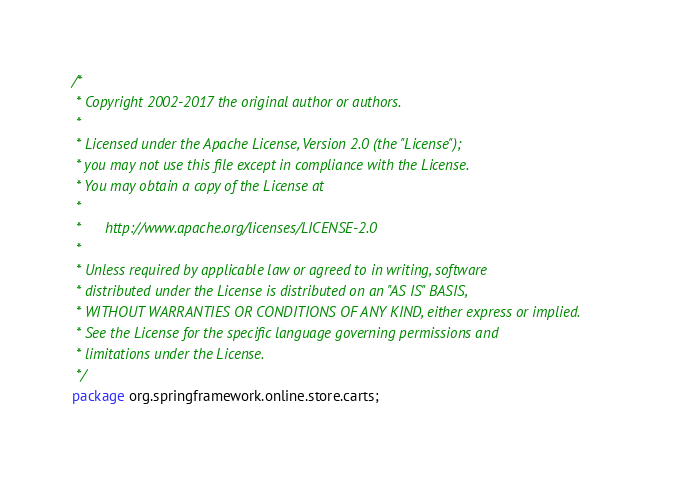<code> <loc_0><loc_0><loc_500><loc_500><_Java_>/*
 * Copyright 2002-2017 the original author or authors.
 *
 * Licensed under the Apache License, Version 2.0 (the "License");
 * you may not use this file except in compliance with the License.
 * You may obtain a copy of the License at
 *
 *      http://www.apache.org/licenses/LICENSE-2.0
 *
 * Unless required by applicable law or agreed to in writing, software
 * distributed under the License is distributed on an "AS IS" BASIS,
 * WITHOUT WARRANTIES OR CONDITIONS OF ANY KIND, either express or implied.
 * See the License for the specific language governing permissions and
 * limitations under the License.
 */
package org.springframework.online.store.carts;
</code> 